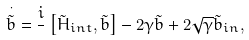<formula> <loc_0><loc_0><loc_500><loc_500>\overset { \cdot } { \tilde { b } } = \frac { i } { } \left [ \tilde { H } _ { i n t } , \tilde { b } \right ] - 2 \gamma \tilde { b } + 2 \sqrt { \gamma } \tilde { b } _ { i n } ,</formula> 